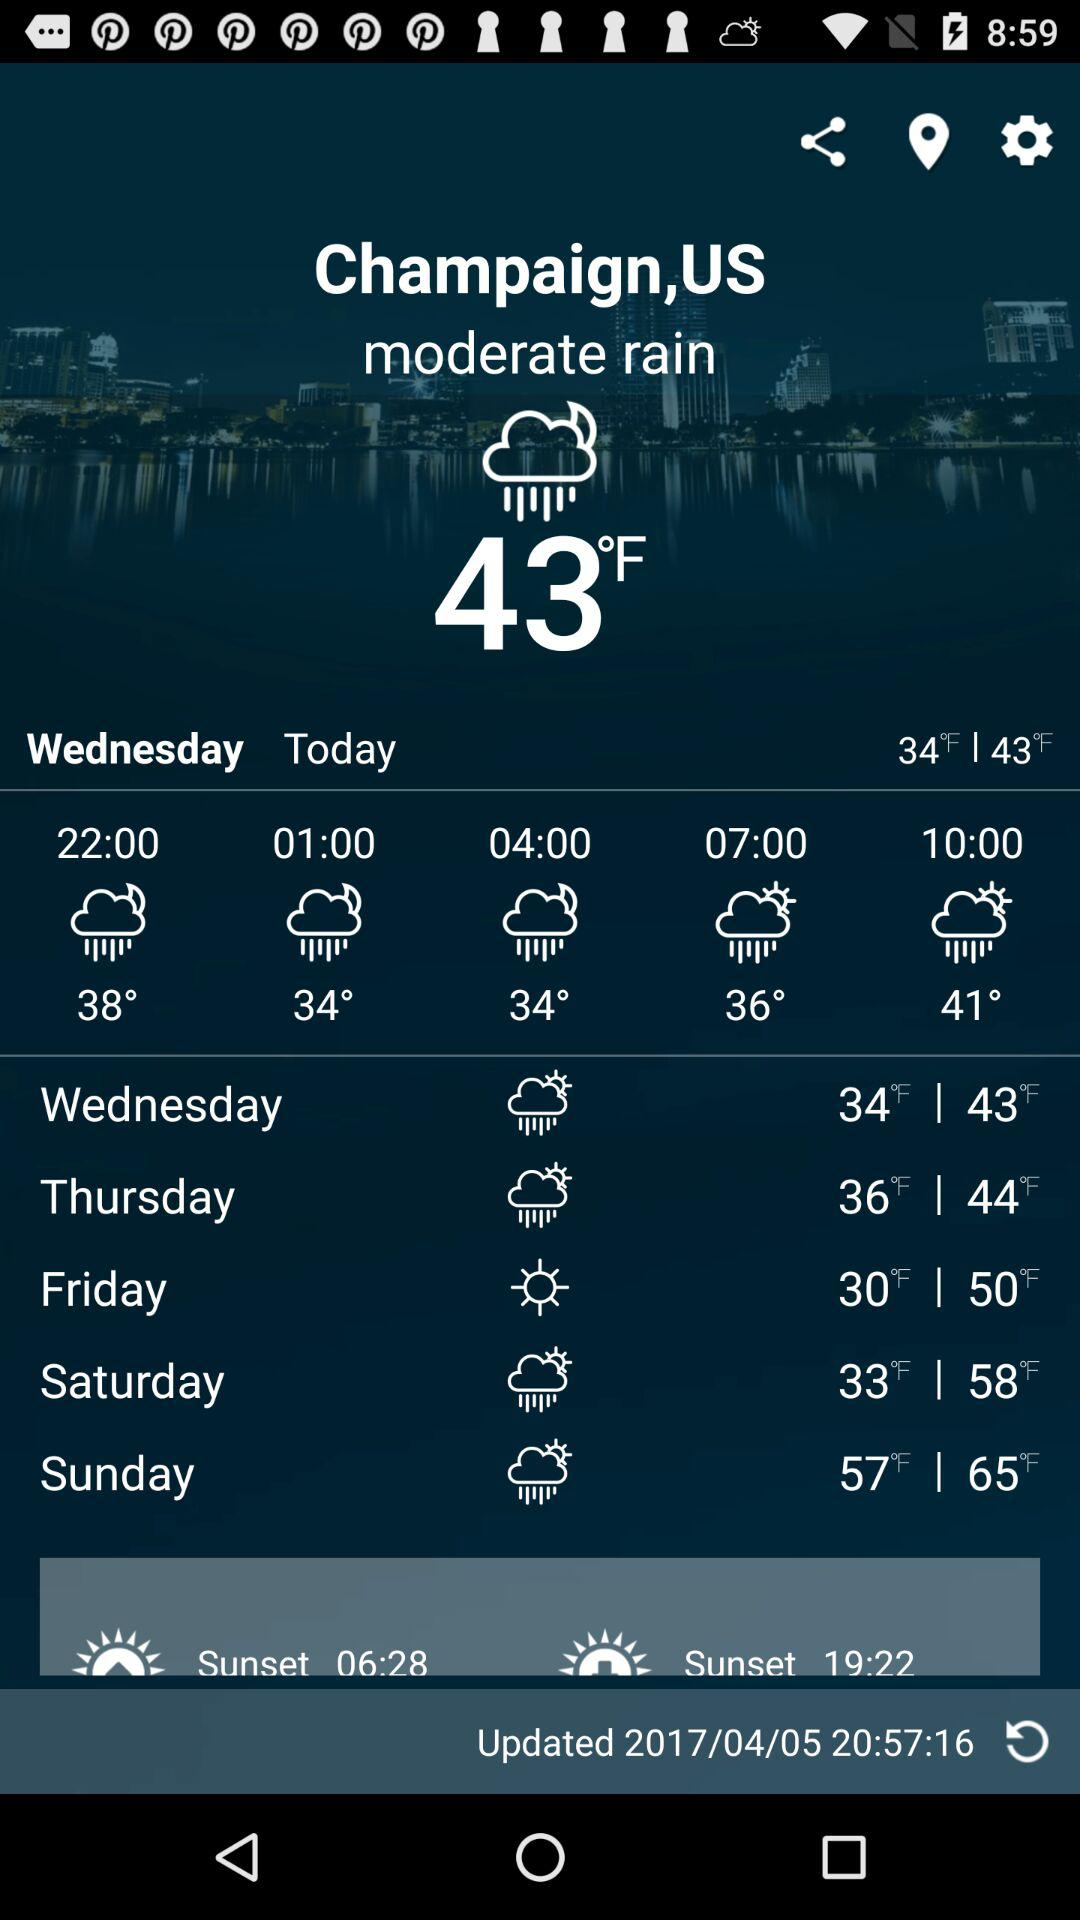How’s the weather? The weather is moderately rainy. 